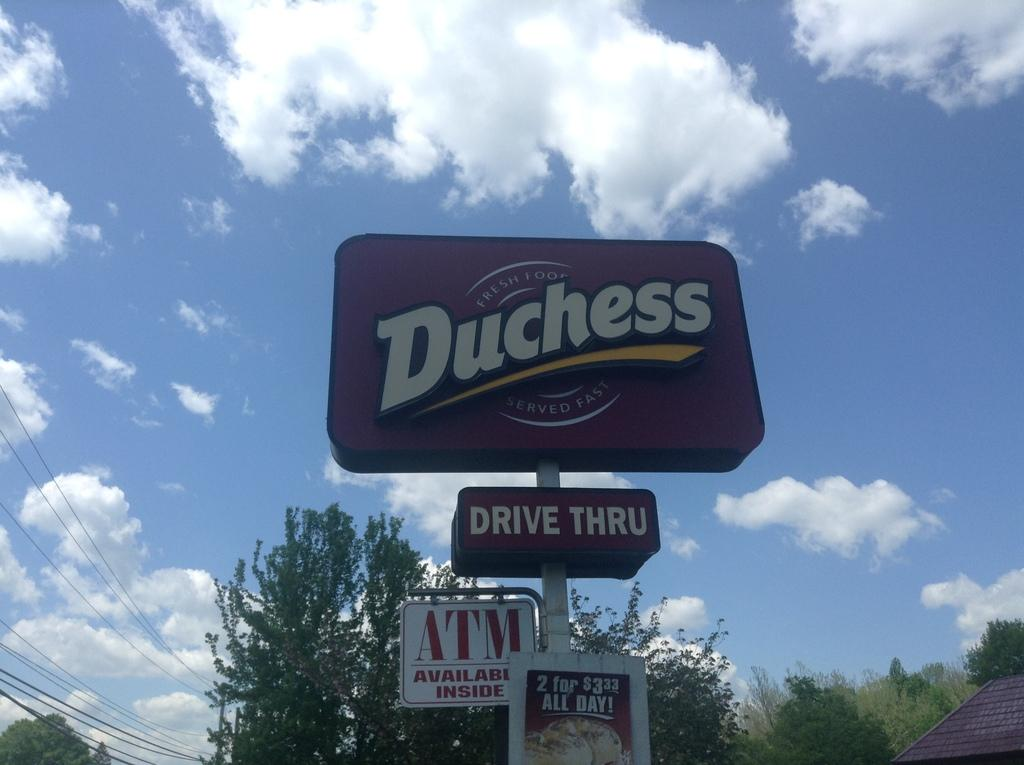Provide a one-sentence caption for the provided image. A business sign for Duchess that promises fresh food served fast and a drive thru, ATM, and 2 for 3 dollar food. 